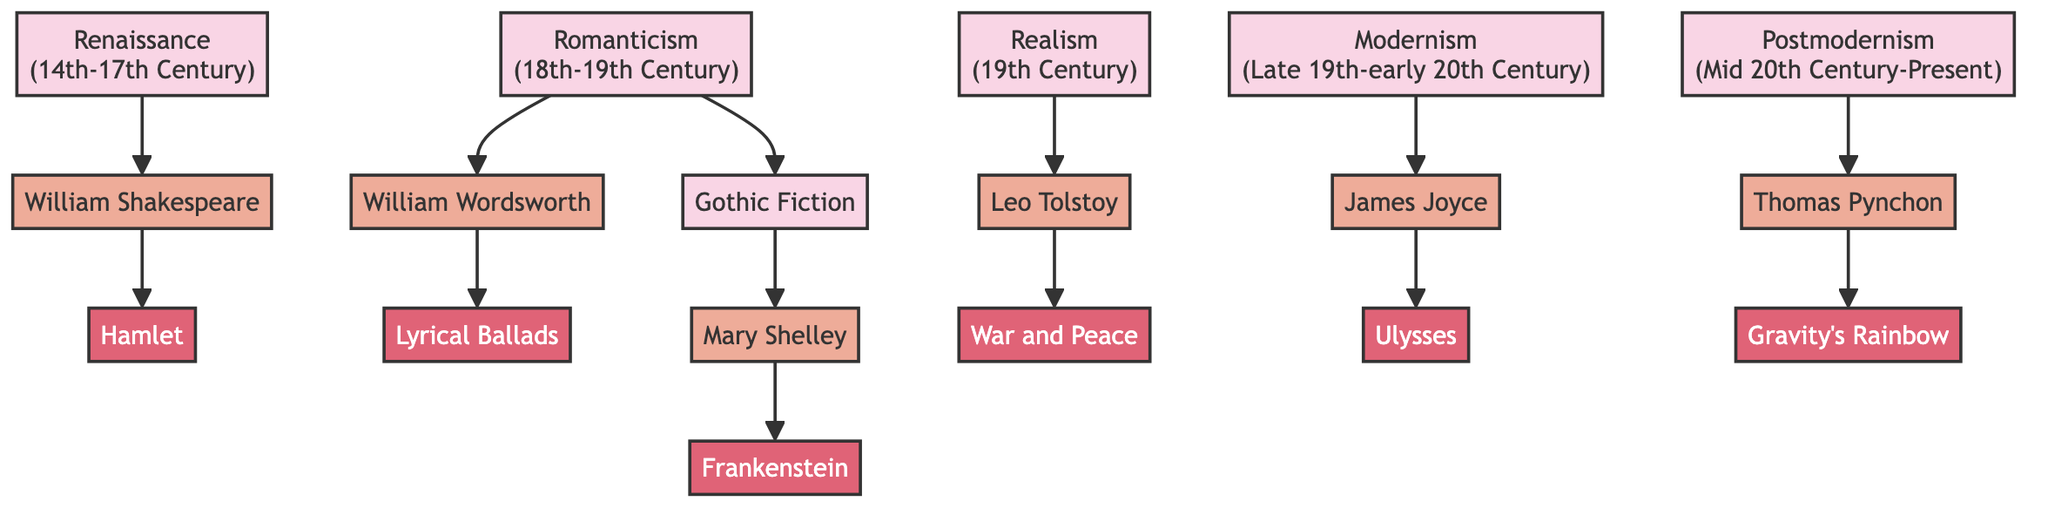What is the first literary movement shown in the diagram? The diagram lists "Renaissance (14th-17th Century)" as the first movement, as it appears at the top and connects directly to William Shakespeare.
Answer: Renaissance (14th-17th Century) How many key authors are represented in the diagram? The diagram shows a total of six key authors (William Shakespeare, William Wordsworth, Mary Shelley, Leo Tolstoy, James Joyce, Thomas Pynchon).
Answer: 6 Which author is linked to the work "Gravity's Rainbow"? "Gravity's Rainbow" is linked to Thomas Pynchon as the diagram connects that work directly to him.
Answer: Thomas Pynchon What is the relationship between Romanticism and Gothic Fiction in the diagram? The diagram indicates that Gothic Fiction is a sub-category of Romanticism, as it branches out from that movement, leading to the author Mary Shelley.
Answer: Sub-category Who wrote "War and Peace"? The author Leo Tolstoy is connected to the work "War and Peace" in the diagram, showing the relationship between the author and the book.
Answer: Leo Tolstoy Which movements are represented in the 19th Century? The movements identified in the 19th Century include Realism, along with Romanticism (which also extends its influence into Gothic Fiction).
Answer: Realism, Romanticism What is the latest literary movement depicted in the diagram? The last movement shown in the diagram is Postmodernism, which spans from the mid-20th century to the present.
Answer: Postmodernism (Mid 20th Century-Present) What is a notable characteristic of the Modernism movement as seen in the diagram? The diagram illustrates that Modernism is marked by innovative authors like James Joyce, showcasing works such as "Ulysses" which highlight its experimental style.
Answer: Innovative authors Which work connects to the author Mary Shelley? "Frankenstein" is the work connected to Mary Shelley, as per the linking in the diagram.
Answer: Frankenstein 